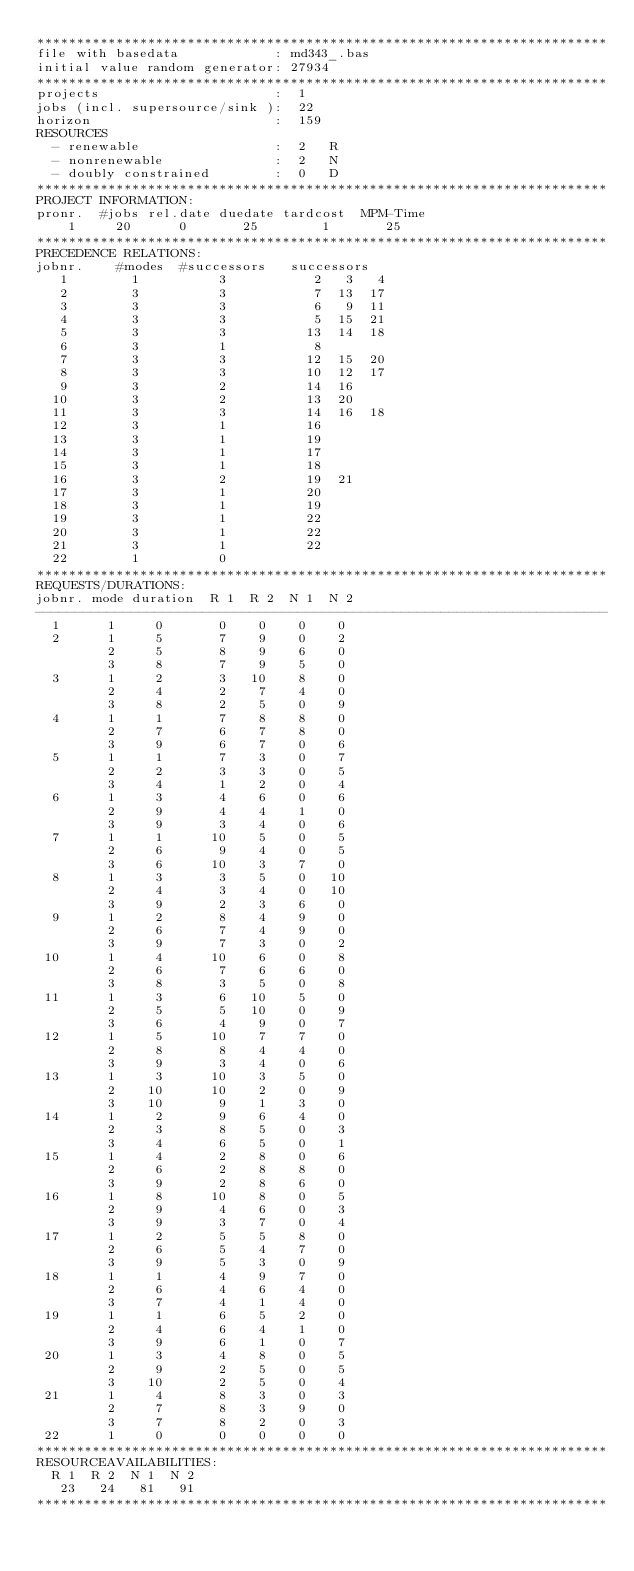<code> <loc_0><loc_0><loc_500><loc_500><_ObjectiveC_>************************************************************************
file with basedata            : md343_.bas
initial value random generator: 27934
************************************************************************
projects                      :  1
jobs (incl. supersource/sink ):  22
horizon                       :  159
RESOURCES
  - renewable                 :  2   R
  - nonrenewable              :  2   N
  - doubly constrained        :  0   D
************************************************************************
PROJECT INFORMATION:
pronr.  #jobs rel.date duedate tardcost  MPM-Time
    1     20      0       25        1       25
************************************************************************
PRECEDENCE RELATIONS:
jobnr.    #modes  #successors   successors
   1        1          3           2   3   4
   2        3          3           7  13  17
   3        3          3           6   9  11
   4        3          3           5  15  21
   5        3          3          13  14  18
   6        3          1           8
   7        3          3          12  15  20
   8        3          3          10  12  17
   9        3          2          14  16
  10        3          2          13  20
  11        3          3          14  16  18
  12        3          1          16
  13        3          1          19
  14        3          1          17
  15        3          1          18
  16        3          2          19  21
  17        3          1          20
  18        3          1          19
  19        3          1          22
  20        3          1          22
  21        3          1          22
  22        1          0        
************************************************************************
REQUESTS/DURATIONS:
jobnr. mode duration  R 1  R 2  N 1  N 2
------------------------------------------------------------------------
  1      1     0       0    0    0    0
  2      1     5       7    9    0    2
         2     5       8    9    6    0
         3     8       7    9    5    0
  3      1     2       3   10    8    0
         2     4       2    7    4    0
         3     8       2    5    0    9
  4      1     1       7    8    8    0
         2     7       6    7    8    0
         3     9       6    7    0    6
  5      1     1       7    3    0    7
         2     2       3    3    0    5
         3     4       1    2    0    4
  6      1     3       4    6    0    6
         2     9       4    4    1    0
         3     9       3    4    0    6
  7      1     1      10    5    0    5
         2     6       9    4    0    5
         3     6      10    3    7    0
  8      1     3       3    5    0   10
         2     4       3    4    0   10
         3     9       2    3    6    0
  9      1     2       8    4    9    0
         2     6       7    4    9    0
         3     9       7    3    0    2
 10      1     4      10    6    0    8
         2     6       7    6    6    0
         3     8       3    5    0    8
 11      1     3       6   10    5    0
         2     5       5   10    0    9
         3     6       4    9    0    7
 12      1     5      10    7    7    0
         2     8       8    4    4    0
         3     9       3    4    0    6
 13      1     3      10    3    5    0
         2    10      10    2    0    9
         3    10       9    1    3    0
 14      1     2       9    6    4    0
         2     3       8    5    0    3
         3     4       6    5    0    1
 15      1     4       2    8    0    6
         2     6       2    8    8    0
         3     9       2    8    6    0
 16      1     8      10    8    0    5
         2     9       4    6    0    3
         3     9       3    7    0    4
 17      1     2       5    5    8    0
         2     6       5    4    7    0
         3     9       5    3    0    9
 18      1     1       4    9    7    0
         2     6       4    6    4    0
         3     7       4    1    4    0
 19      1     1       6    5    2    0
         2     4       6    4    1    0
         3     9       6    1    0    7
 20      1     3       4    8    0    5
         2     9       2    5    0    5
         3    10       2    5    0    4
 21      1     4       8    3    0    3
         2     7       8    3    9    0
         3     7       8    2    0    3
 22      1     0       0    0    0    0
************************************************************************
RESOURCEAVAILABILITIES:
  R 1  R 2  N 1  N 2
   23   24   81   91
************************************************************************
</code> 